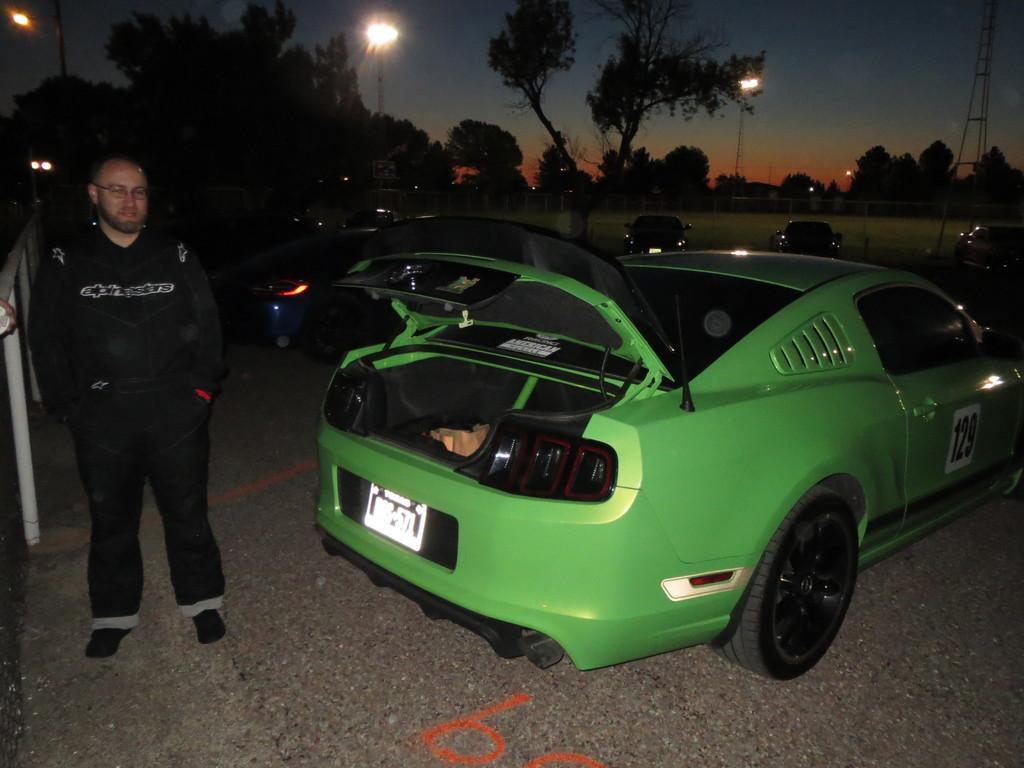Could you give a brief overview of what you see in this image? On the left side there is a person standing. Near to him there is a fencing. On the right side there is a car with a number. In the back there are many cars, lights poles, trees and sky. Also there is tower. 